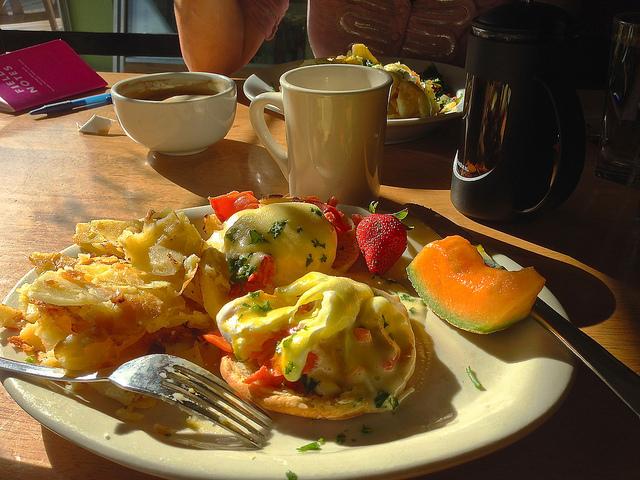Has someone started eating this dish yet?
Short answer required. Yes. Has the meal begun?
Short answer required. Yes. What tells you this is a breakfast dish?
Quick response, please. Eggs. What types of fruit are shown?
Quick response, please. Strawberry and cantaloupe. Shouldn't the fruits be on a separate plate?
Write a very short answer. No. 